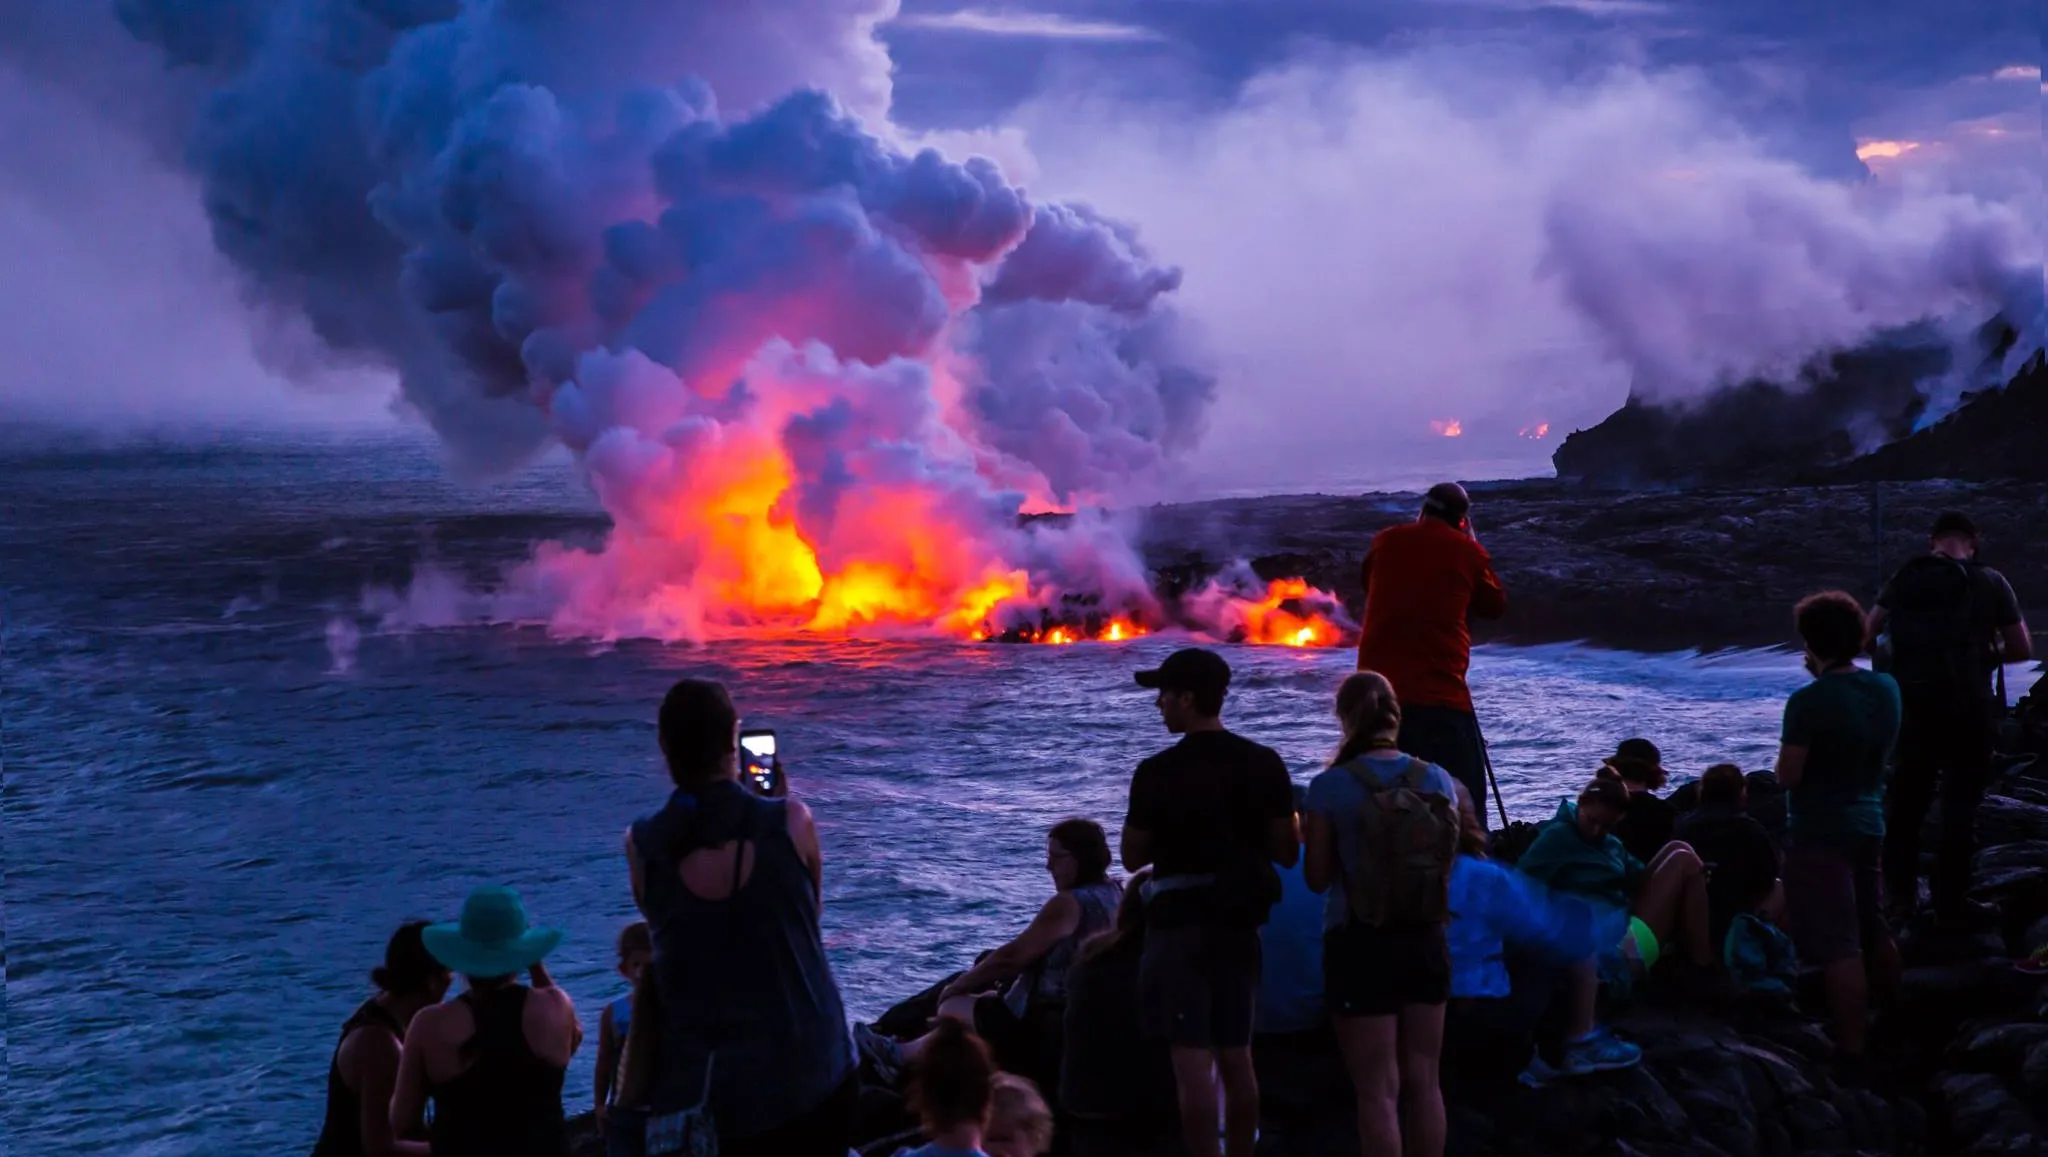What are the key elements in this picture? This image features a powerfully dynamic scene at Hawaii Volcanoes National Park. A diverse group of onlookers gathers on a rocky outcrop, captivated by the natural spectacle before them. The key elements include the dramatic eruption of the volcano, emitting a large plume of smoke and ash that contrasts sharply with the fading light of dusk. Bright lava flows into the ocean, creating a striking orange glow and generating clouds of steam where the molten rock meets the water. The observers' silhouettes add a human element to this raw display of nature's force, offering a scale to the scene and highlighting the human fascination with natural phenomena. 